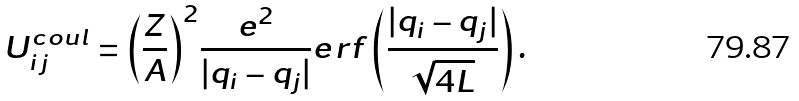<formula> <loc_0><loc_0><loc_500><loc_500>U _ { i j } ^ { c o u l } = { \left ( \frac { Z } { A } \right ) } ^ { 2 } \frac { e ^ { 2 } } { | { q } _ { i } - { q } _ { j } | } e r f \left ( \frac { | { q } _ { i } - { q } _ { j } | } { \sqrt { 4 L } } \right ) .</formula> 